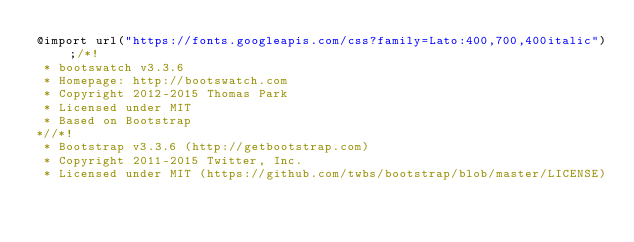Convert code to text. <code><loc_0><loc_0><loc_500><loc_500><_CSS_>@import url("https://fonts.googleapis.com/css?family=Lato:400,700,400italic");/*!
 * bootswatch v3.3.6
 * Homepage: http://bootswatch.com
 * Copyright 2012-2015 Thomas Park
 * Licensed under MIT
 * Based on Bootstrap
*//*!
 * Bootstrap v3.3.6 (http://getbootstrap.com)
 * Copyright 2011-2015 Twitter, Inc.
 * Licensed under MIT (https://github.com/twbs/bootstrap/blob/master/LICENSE)</code> 